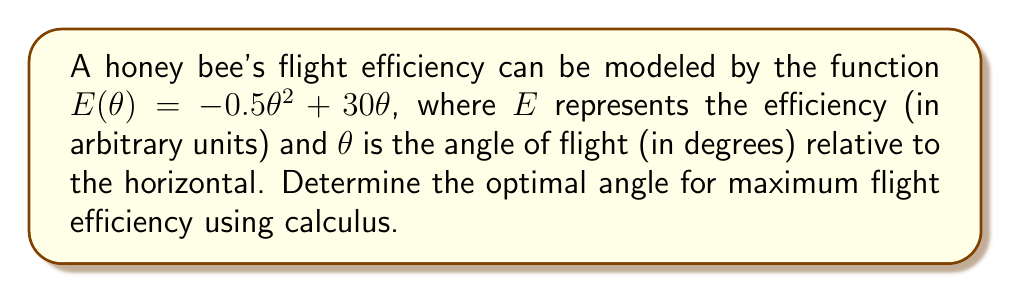Solve this math problem. To find the optimal angle for maximum flight efficiency, we need to find the maximum of the function $E(\theta)$. This can be done by following these steps:

1. Find the derivative of $E(\theta)$ with respect to $\theta$:
   $$\frac{dE}{d\theta} = -\theta + 30$$

2. Set the derivative equal to zero to find the critical point:
   $$-\theta + 30 = 0$$
   $$\theta = 30$$

3. Verify that this critical point is a maximum by checking the second derivative:
   $$\frac{d^2E}{d\theta^2} = -1$$
   Since the second derivative is negative, the critical point is a maximum.

4. Therefore, the optimal angle for maximum flight efficiency is 30 degrees.

To visualize this:

[asy]
import graph;
size(200,150);
real f(real x) {return -0.5*x^2 + 30*x;}
draw(graph(f,0,60));
dot((30,f(30)));
label("Maximum",((30,f(30))),N);
xaxis("$\theta$ (degrees)",0,60,Arrow);
yaxis("$E(\theta)$",0,450,Arrow);
[/asy]
Answer: $30°$ 